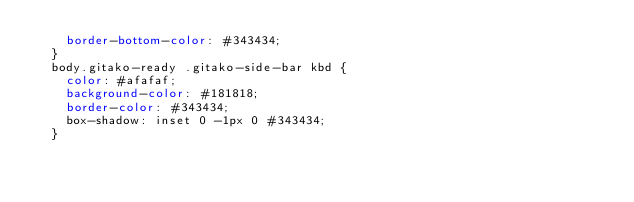<code> <loc_0><loc_0><loc_500><loc_500><_CSS_>    border-bottom-color: #343434;
  }
  body.gitako-ready .gitako-side-bar kbd {
    color: #afafaf;
    background-color: #181818;
    border-color: #343434;
    box-shadow: inset 0 -1px 0 #343434;
  }</code> 